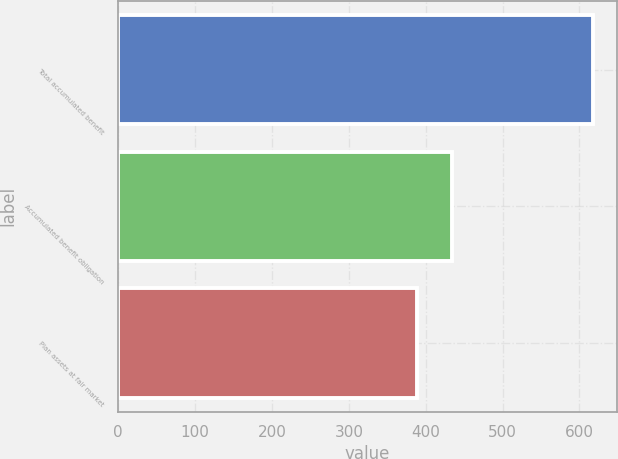Convert chart to OTSL. <chart><loc_0><loc_0><loc_500><loc_500><bar_chart><fcel>Total accumulated benefit<fcel>Accumulated benefit obligation<fcel>Plan assets at fair market<nl><fcel>618<fcel>434.8<fcel>388.8<nl></chart> 